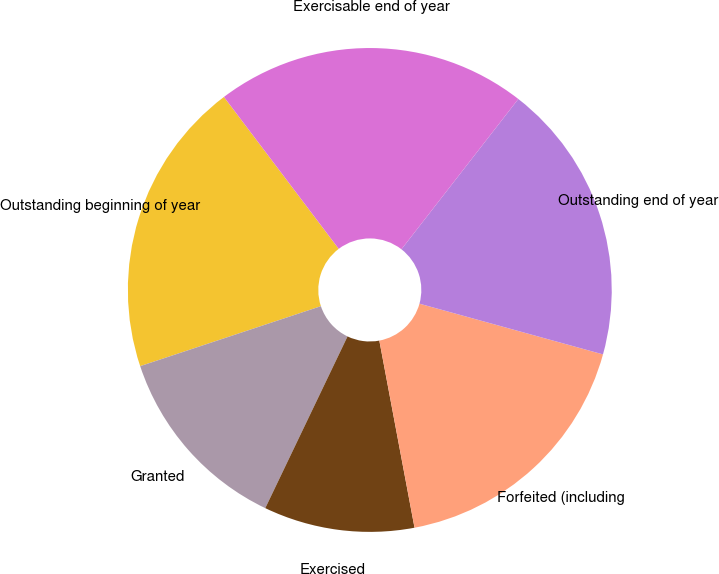Convert chart to OTSL. <chart><loc_0><loc_0><loc_500><loc_500><pie_chart><fcel>Outstanding beginning of year<fcel>Granted<fcel>Exercised<fcel>Forfeited (including<fcel>Outstanding end of year<fcel>Exercisable end of year<nl><fcel>19.8%<fcel>12.79%<fcel>10.07%<fcel>17.75%<fcel>18.77%<fcel>20.82%<nl></chart> 